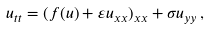<formula> <loc_0><loc_0><loc_500><loc_500>u _ { t t } = ( f ( u ) + \varepsilon u _ { x x } ) _ { x x } + \sigma u _ { y y } \, ,</formula> 